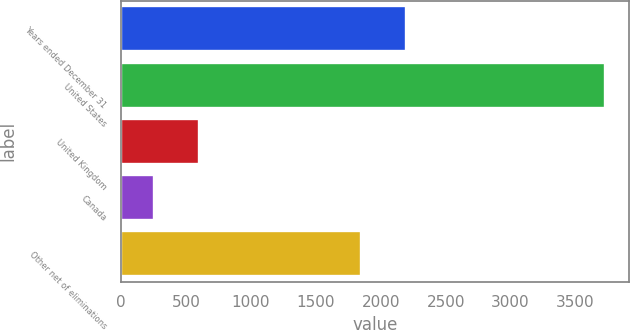Convert chart. <chart><loc_0><loc_0><loc_500><loc_500><bar_chart><fcel>Years ended December 31<fcel>United States<fcel>United Kingdom<fcel>Canada<fcel>Other net of eliminations<nl><fcel>2193.4<fcel>3725<fcel>598.4<fcel>251<fcel>1846<nl></chart> 